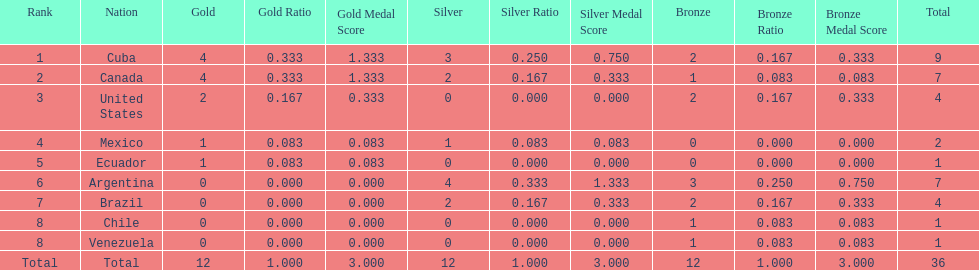Which nation won gold but did not win silver? United States. 